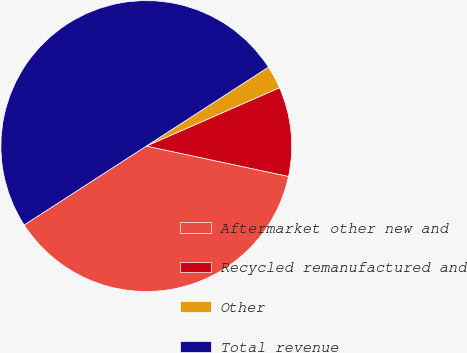Convert chart to OTSL. <chart><loc_0><loc_0><loc_500><loc_500><pie_chart><fcel>Aftermarket other new and<fcel>Recycled remanufactured and<fcel>Other<fcel>Total revenue<nl><fcel>37.52%<fcel>9.92%<fcel>2.56%<fcel>50.0%<nl></chart> 